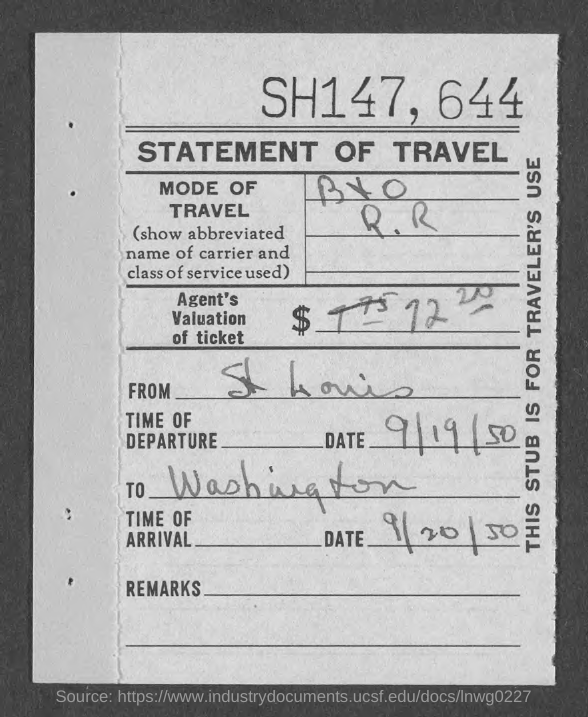Draw attention to some important aspects in this diagram. The date of departure is September 19, 1950. The title of the document is 'Statement of Travel'. The location is Washington. The date of arrival is September 20, 1950. 